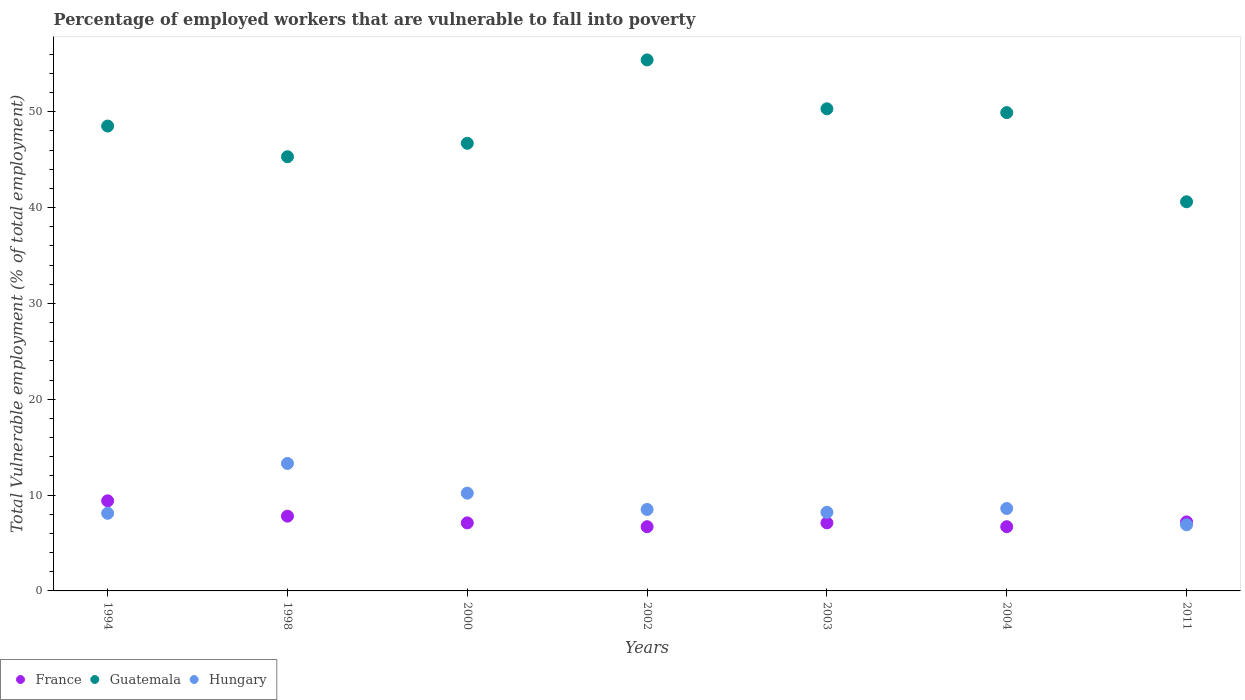How many different coloured dotlines are there?
Ensure brevity in your answer.  3. Is the number of dotlines equal to the number of legend labels?
Your answer should be very brief. Yes. What is the percentage of employed workers who are vulnerable to fall into poverty in France in 2000?
Ensure brevity in your answer.  7.1. Across all years, what is the maximum percentage of employed workers who are vulnerable to fall into poverty in Hungary?
Give a very brief answer. 13.3. Across all years, what is the minimum percentage of employed workers who are vulnerable to fall into poverty in Hungary?
Keep it short and to the point. 6.9. What is the total percentage of employed workers who are vulnerable to fall into poverty in Hungary in the graph?
Ensure brevity in your answer.  63.8. What is the difference between the percentage of employed workers who are vulnerable to fall into poverty in Guatemala in 1998 and that in 2011?
Your answer should be compact. 4.7. What is the difference between the percentage of employed workers who are vulnerable to fall into poverty in France in 2002 and the percentage of employed workers who are vulnerable to fall into poverty in Guatemala in 2003?
Your answer should be compact. -43.6. What is the average percentage of employed workers who are vulnerable to fall into poverty in Hungary per year?
Offer a very short reply. 9.11. In the year 2003, what is the difference between the percentage of employed workers who are vulnerable to fall into poverty in France and percentage of employed workers who are vulnerable to fall into poverty in Guatemala?
Offer a very short reply. -43.2. In how many years, is the percentage of employed workers who are vulnerable to fall into poverty in Guatemala greater than 4 %?
Your answer should be compact. 7. What is the ratio of the percentage of employed workers who are vulnerable to fall into poverty in France in 1998 to that in 2000?
Ensure brevity in your answer.  1.1. Is the percentage of employed workers who are vulnerable to fall into poverty in France in 1998 less than that in 2011?
Make the answer very short. No. What is the difference between the highest and the second highest percentage of employed workers who are vulnerable to fall into poverty in France?
Your answer should be very brief. 1.6. What is the difference between the highest and the lowest percentage of employed workers who are vulnerable to fall into poverty in Hungary?
Make the answer very short. 6.4. Does the percentage of employed workers who are vulnerable to fall into poverty in Guatemala monotonically increase over the years?
Offer a very short reply. No. How many dotlines are there?
Offer a terse response. 3. Are the values on the major ticks of Y-axis written in scientific E-notation?
Your answer should be very brief. No. Does the graph contain any zero values?
Make the answer very short. No. Does the graph contain grids?
Your response must be concise. No. Where does the legend appear in the graph?
Offer a terse response. Bottom left. What is the title of the graph?
Provide a short and direct response. Percentage of employed workers that are vulnerable to fall into poverty. What is the label or title of the Y-axis?
Your answer should be very brief. Total Vulnerable employment (% of total employment). What is the Total Vulnerable employment (% of total employment) of France in 1994?
Keep it short and to the point. 9.4. What is the Total Vulnerable employment (% of total employment) in Guatemala in 1994?
Keep it short and to the point. 48.5. What is the Total Vulnerable employment (% of total employment) in Hungary in 1994?
Your answer should be compact. 8.1. What is the Total Vulnerable employment (% of total employment) in France in 1998?
Your response must be concise. 7.8. What is the Total Vulnerable employment (% of total employment) in Guatemala in 1998?
Offer a terse response. 45.3. What is the Total Vulnerable employment (% of total employment) of Hungary in 1998?
Ensure brevity in your answer.  13.3. What is the Total Vulnerable employment (% of total employment) of France in 2000?
Your answer should be very brief. 7.1. What is the Total Vulnerable employment (% of total employment) in Guatemala in 2000?
Make the answer very short. 46.7. What is the Total Vulnerable employment (% of total employment) in Hungary in 2000?
Your response must be concise. 10.2. What is the Total Vulnerable employment (% of total employment) in France in 2002?
Offer a very short reply. 6.7. What is the Total Vulnerable employment (% of total employment) of Guatemala in 2002?
Keep it short and to the point. 55.4. What is the Total Vulnerable employment (% of total employment) in France in 2003?
Make the answer very short. 7.1. What is the Total Vulnerable employment (% of total employment) of Guatemala in 2003?
Offer a terse response. 50.3. What is the Total Vulnerable employment (% of total employment) of Hungary in 2003?
Your response must be concise. 8.2. What is the Total Vulnerable employment (% of total employment) in France in 2004?
Offer a very short reply. 6.7. What is the Total Vulnerable employment (% of total employment) of Guatemala in 2004?
Ensure brevity in your answer.  49.9. What is the Total Vulnerable employment (% of total employment) of Hungary in 2004?
Provide a short and direct response. 8.6. What is the Total Vulnerable employment (% of total employment) in France in 2011?
Provide a succinct answer. 7.2. What is the Total Vulnerable employment (% of total employment) in Guatemala in 2011?
Offer a very short reply. 40.6. What is the Total Vulnerable employment (% of total employment) in Hungary in 2011?
Offer a terse response. 6.9. Across all years, what is the maximum Total Vulnerable employment (% of total employment) of France?
Give a very brief answer. 9.4. Across all years, what is the maximum Total Vulnerable employment (% of total employment) in Guatemala?
Provide a succinct answer. 55.4. Across all years, what is the maximum Total Vulnerable employment (% of total employment) of Hungary?
Your response must be concise. 13.3. Across all years, what is the minimum Total Vulnerable employment (% of total employment) of France?
Your answer should be compact. 6.7. Across all years, what is the minimum Total Vulnerable employment (% of total employment) in Guatemala?
Provide a short and direct response. 40.6. Across all years, what is the minimum Total Vulnerable employment (% of total employment) of Hungary?
Your answer should be compact. 6.9. What is the total Total Vulnerable employment (% of total employment) of France in the graph?
Ensure brevity in your answer.  52. What is the total Total Vulnerable employment (% of total employment) in Guatemala in the graph?
Keep it short and to the point. 336.7. What is the total Total Vulnerable employment (% of total employment) in Hungary in the graph?
Provide a short and direct response. 63.8. What is the difference between the Total Vulnerable employment (% of total employment) in France in 1994 and that in 1998?
Your answer should be very brief. 1.6. What is the difference between the Total Vulnerable employment (% of total employment) in Guatemala in 1994 and that in 1998?
Ensure brevity in your answer.  3.2. What is the difference between the Total Vulnerable employment (% of total employment) in France in 1994 and that in 2002?
Make the answer very short. 2.7. What is the difference between the Total Vulnerable employment (% of total employment) of Hungary in 1994 and that in 2002?
Provide a succinct answer. -0.4. What is the difference between the Total Vulnerable employment (% of total employment) of France in 1994 and that in 2003?
Your response must be concise. 2.3. What is the difference between the Total Vulnerable employment (% of total employment) in Guatemala in 1994 and that in 2004?
Give a very brief answer. -1.4. What is the difference between the Total Vulnerable employment (% of total employment) of Hungary in 1994 and that in 2004?
Provide a short and direct response. -0.5. What is the difference between the Total Vulnerable employment (% of total employment) of Guatemala in 1994 and that in 2011?
Provide a short and direct response. 7.9. What is the difference between the Total Vulnerable employment (% of total employment) of France in 1998 and that in 2000?
Your response must be concise. 0.7. What is the difference between the Total Vulnerable employment (% of total employment) of Guatemala in 1998 and that in 2000?
Keep it short and to the point. -1.4. What is the difference between the Total Vulnerable employment (% of total employment) in France in 1998 and that in 2002?
Provide a short and direct response. 1.1. What is the difference between the Total Vulnerable employment (% of total employment) in Hungary in 1998 and that in 2002?
Provide a short and direct response. 4.8. What is the difference between the Total Vulnerable employment (% of total employment) of France in 1998 and that in 2003?
Make the answer very short. 0.7. What is the difference between the Total Vulnerable employment (% of total employment) in France in 1998 and that in 2011?
Your answer should be compact. 0.6. What is the difference between the Total Vulnerable employment (% of total employment) of Guatemala in 1998 and that in 2011?
Your answer should be compact. 4.7. What is the difference between the Total Vulnerable employment (% of total employment) in Guatemala in 2000 and that in 2002?
Provide a succinct answer. -8.7. What is the difference between the Total Vulnerable employment (% of total employment) of Hungary in 2000 and that in 2002?
Keep it short and to the point. 1.7. What is the difference between the Total Vulnerable employment (% of total employment) of Hungary in 2000 and that in 2003?
Make the answer very short. 2. What is the difference between the Total Vulnerable employment (% of total employment) of Hungary in 2000 and that in 2011?
Your answer should be very brief. 3.3. What is the difference between the Total Vulnerable employment (% of total employment) in France in 2002 and that in 2003?
Keep it short and to the point. -0.4. What is the difference between the Total Vulnerable employment (% of total employment) in France in 2002 and that in 2004?
Keep it short and to the point. 0. What is the difference between the Total Vulnerable employment (% of total employment) of Hungary in 2002 and that in 2004?
Provide a short and direct response. -0.1. What is the difference between the Total Vulnerable employment (% of total employment) in France in 2002 and that in 2011?
Provide a short and direct response. -0.5. What is the difference between the Total Vulnerable employment (% of total employment) of Guatemala in 2002 and that in 2011?
Keep it short and to the point. 14.8. What is the difference between the Total Vulnerable employment (% of total employment) of Hungary in 2002 and that in 2011?
Offer a very short reply. 1.6. What is the difference between the Total Vulnerable employment (% of total employment) in France in 2003 and that in 2004?
Your response must be concise. 0.4. What is the difference between the Total Vulnerable employment (% of total employment) in Guatemala in 2003 and that in 2004?
Your response must be concise. 0.4. What is the difference between the Total Vulnerable employment (% of total employment) of Hungary in 2003 and that in 2004?
Keep it short and to the point. -0.4. What is the difference between the Total Vulnerable employment (% of total employment) in Hungary in 2003 and that in 2011?
Keep it short and to the point. 1.3. What is the difference between the Total Vulnerable employment (% of total employment) of France in 1994 and the Total Vulnerable employment (% of total employment) of Guatemala in 1998?
Give a very brief answer. -35.9. What is the difference between the Total Vulnerable employment (% of total employment) of Guatemala in 1994 and the Total Vulnerable employment (% of total employment) of Hungary in 1998?
Give a very brief answer. 35.2. What is the difference between the Total Vulnerable employment (% of total employment) in France in 1994 and the Total Vulnerable employment (% of total employment) in Guatemala in 2000?
Give a very brief answer. -37.3. What is the difference between the Total Vulnerable employment (% of total employment) in Guatemala in 1994 and the Total Vulnerable employment (% of total employment) in Hungary in 2000?
Keep it short and to the point. 38.3. What is the difference between the Total Vulnerable employment (% of total employment) of France in 1994 and the Total Vulnerable employment (% of total employment) of Guatemala in 2002?
Keep it short and to the point. -46. What is the difference between the Total Vulnerable employment (% of total employment) in France in 1994 and the Total Vulnerable employment (% of total employment) in Hungary in 2002?
Offer a very short reply. 0.9. What is the difference between the Total Vulnerable employment (% of total employment) in France in 1994 and the Total Vulnerable employment (% of total employment) in Guatemala in 2003?
Keep it short and to the point. -40.9. What is the difference between the Total Vulnerable employment (% of total employment) in France in 1994 and the Total Vulnerable employment (% of total employment) in Hungary in 2003?
Your response must be concise. 1.2. What is the difference between the Total Vulnerable employment (% of total employment) of Guatemala in 1994 and the Total Vulnerable employment (% of total employment) of Hungary in 2003?
Make the answer very short. 40.3. What is the difference between the Total Vulnerable employment (% of total employment) in France in 1994 and the Total Vulnerable employment (% of total employment) in Guatemala in 2004?
Ensure brevity in your answer.  -40.5. What is the difference between the Total Vulnerable employment (% of total employment) of Guatemala in 1994 and the Total Vulnerable employment (% of total employment) of Hungary in 2004?
Offer a terse response. 39.9. What is the difference between the Total Vulnerable employment (% of total employment) of France in 1994 and the Total Vulnerable employment (% of total employment) of Guatemala in 2011?
Offer a very short reply. -31.2. What is the difference between the Total Vulnerable employment (% of total employment) in Guatemala in 1994 and the Total Vulnerable employment (% of total employment) in Hungary in 2011?
Provide a succinct answer. 41.6. What is the difference between the Total Vulnerable employment (% of total employment) in France in 1998 and the Total Vulnerable employment (% of total employment) in Guatemala in 2000?
Your response must be concise. -38.9. What is the difference between the Total Vulnerable employment (% of total employment) of France in 1998 and the Total Vulnerable employment (% of total employment) of Hungary in 2000?
Keep it short and to the point. -2.4. What is the difference between the Total Vulnerable employment (% of total employment) of Guatemala in 1998 and the Total Vulnerable employment (% of total employment) of Hungary in 2000?
Give a very brief answer. 35.1. What is the difference between the Total Vulnerable employment (% of total employment) of France in 1998 and the Total Vulnerable employment (% of total employment) of Guatemala in 2002?
Ensure brevity in your answer.  -47.6. What is the difference between the Total Vulnerable employment (% of total employment) of France in 1998 and the Total Vulnerable employment (% of total employment) of Hungary in 2002?
Offer a very short reply. -0.7. What is the difference between the Total Vulnerable employment (% of total employment) in Guatemala in 1998 and the Total Vulnerable employment (% of total employment) in Hungary in 2002?
Provide a short and direct response. 36.8. What is the difference between the Total Vulnerable employment (% of total employment) of France in 1998 and the Total Vulnerable employment (% of total employment) of Guatemala in 2003?
Make the answer very short. -42.5. What is the difference between the Total Vulnerable employment (% of total employment) in Guatemala in 1998 and the Total Vulnerable employment (% of total employment) in Hungary in 2003?
Ensure brevity in your answer.  37.1. What is the difference between the Total Vulnerable employment (% of total employment) of France in 1998 and the Total Vulnerable employment (% of total employment) of Guatemala in 2004?
Provide a short and direct response. -42.1. What is the difference between the Total Vulnerable employment (% of total employment) of France in 1998 and the Total Vulnerable employment (% of total employment) of Hungary in 2004?
Keep it short and to the point. -0.8. What is the difference between the Total Vulnerable employment (% of total employment) of Guatemala in 1998 and the Total Vulnerable employment (% of total employment) of Hungary in 2004?
Provide a succinct answer. 36.7. What is the difference between the Total Vulnerable employment (% of total employment) in France in 1998 and the Total Vulnerable employment (% of total employment) in Guatemala in 2011?
Ensure brevity in your answer.  -32.8. What is the difference between the Total Vulnerable employment (% of total employment) of Guatemala in 1998 and the Total Vulnerable employment (% of total employment) of Hungary in 2011?
Offer a very short reply. 38.4. What is the difference between the Total Vulnerable employment (% of total employment) of France in 2000 and the Total Vulnerable employment (% of total employment) of Guatemala in 2002?
Your answer should be compact. -48.3. What is the difference between the Total Vulnerable employment (% of total employment) of France in 2000 and the Total Vulnerable employment (% of total employment) of Hungary in 2002?
Give a very brief answer. -1.4. What is the difference between the Total Vulnerable employment (% of total employment) of Guatemala in 2000 and the Total Vulnerable employment (% of total employment) of Hungary in 2002?
Your answer should be very brief. 38.2. What is the difference between the Total Vulnerable employment (% of total employment) in France in 2000 and the Total Vulnerable employment (% of total employment) in Guatemala in 2003?
Make the answer very short. -43.2. What is the difference between the Total Vulnerable employment (% of total employment) of Guatemala in 2000 and the Total Vulnerable employment (% of total employment) of Hungary in 2003?
Give a very brief answer. 38.5. What is the difference between the Total Vulnerable employment (% of total employment) of France in 2000 and the Total Vulnerable employment (% of total employment) of Guatemala in 2004?
Ensure brevity in your answer.  -42.8. What is the difference between the Total Vulnerable employment (% of total employment) of France in 2000 and the Total Vulnerable employment (% of total employment) of Hungary in 2004?
Provide a succinct answer. -1.5. What is the difference between the Total Vulnerable employment (% of total employment) in Guatemala in 2000 and the Total Vulnerable employment (% of total employment) in Hungary in 2004?
Provide a succinct answer. 38.1. What is the difference between the Total Vulnerable employment (% of total employment) in France in 2000 and the Total Vulnerable employment (% of total employment) in Guatemala in 2011?
Offer a terse response. -33.5. What is the difference between the Total Vulnerable employment (% of total employment) in Guatemala in 2000 and the Total Vulnerable employment (% of total employment) in Hungary in 2011?
Provide a short and direct response. 39.8. What is the difference between the Total Vulnerable employment (% of total employment) in France in 2002 and the Total Vulnerable employment (% of total employment) in Guatemala in 2003?
Ensure brevity in your answer.  -43.6. What is the difference between the Total Vulnerable employment (% of total employment) in France in 2002 and the Total Vulnerable employment (% of total employment) in Hungary in 2003?
Provide a short and direct response. -1.5. What is the difference between the Total Vulnerable employment (% of total employment) of Guatemala in 2002 and the Total Vulnerable employment (% of total employment) of Hungary in 2003?
Offer a very short reply. 47.2. What is the difference between the Total Vulnerable employment (% of total employment) of France in 2002 and the Total Vulnerable employment (% of total employment) of Guatemala in 2004?
Keep it short and to the point. -43.2. What is the difference between the Total Vulnerable employment (% of total employment) in Guatemala in 2002 and the Total Vulnerable employment (% of total employment) in Hungary in 2004?
Provide a succinct answer. 46.8. What is the difference between the Total Vulnerable employment (% of total employment) of France in 2002 and the Total Vulnerable employment (% of total employment) of Guatemala in 2011?
Your response must be concise. -33.9. What is the difference between the Total Vulnerable employment (% of total employment) of Guatemala in 2002 and the Total Vulnerable employment (% of total employment) of Hungary in 2011?
Your answer should be compact. 48.5. What is the difference between the Total Vulnerable employment (% of total employment) of France in 2003 and the Total Vulnerable employment (% of total employment) of Guatemala in 2004?
Your answer should be compact. -42.8. What is the difference between the Total Vulnerable employment (% of total employment) in France in 2003 and the Total Vulnerable employment (% of total employment) in Hungary in 2004?
Give a very brief answer. -1.5. What is the difference between the Total Vulnerable employment (% of total employment) of Guatemala in 2003 and the Total Vulnerable employment (% of total employment) of Hungary in 2004?
Offer a very short reply. 41.7. What is the difference between the Total Vulnerable employment (% of total employment) in France in 2003 and the Total Vulnerable employment (% of total employment) in Guatemala in 2011?
Give a very brief answer. -33.5. What is the difference between the Total Vulnerable employment (% of total employment) in Guatemala in 2003 and the Total Vulnerable employment (% of total employment) in Hungary in 2011?
Offer a very short reply. 43.4. What is the difference between the Total Vulnerable employment (% of total employment) of France in 2004 and the Total Vulnerable employment (% of total employment) of Guatemala in 2011?
Your answer should be very brief. -33.9. What is the average Total Vulnerable employment (% of total employment) in France per year?
Offer a terse response. 7.43. What is the average Total Vulnerable employment (% of total employment) of Guatemala per year?
Ensure brevity in your answer.  48.1. What is the average Total Vulnerable employment (% of total employment) of Hungary per year?
Your response must be concise. 9.11. In the year 1994, what is the difference between the Total Vulnerable employment (% of total employment) in France and Total Vulnerable employment (% of total employment) in Guatemala?
Offer a very short reply. -39.1. In the year 1994, what is the difference between the Total Vulnerable employment (% of total employment) of France and Total Vulnerable employment (% of total employment) of Hungary?
Offer a terse response. 1.3. In the year 1994, what is the difference between the Total Vulnerable employment (% of total employment) in Guatemala and Total Vulnerable employment (% of total employment) in Hungary?
Your response must be concise. 40.4. In the year 1998, what is the difference between the Total Vulnerable employment (% of total employment) in France and Total Vulnerable employment (% of total employment) in Guatemala?
Provide a succinct answer. -37.5. In the year 1998, what is the difference between the Total Vulnerable employment (% of total employment) in France and Total Vulnerable employment (% of total employment) in Hungary?
Make the answer very short. -5.5. In the year 2000, what is the difference between the Total Vulnerable employment (% of total employment) of France and Total Vulnerable employment (% of total employment) of Guatemala?
Keep it short and to the point. -39.6. In the year 2000, what is the difference between the Total Vulnerable employment (% of total employment) in France and Total Vulnerable employment (% of total employment) in Hungary?
Keep it short and to the point. -3.1. In the year 2000, what is the difference between the Total Vulnerable employment (% of total employment) of Guatemala and Total Vulnerable employment (% of total employment) of Hungary?
Provide a short and direct response. 36.5. In the year 2002, what is the difference between the Total Vulnerable employment (% of total employment) of France and Total Vulnerable employment (% of total employment) of Guatemala?
Provide a short and direct response. -48.7. In the year 2002, what is the difference between the Total Vulnerable employment (% of total employment) in Guatemala and Total Vulnerable employment (% of total employment) in Hungary?
Give a very brief answer. 46.9. In the year 2003, what is the difference between the Total Vulnerable employment (% of total employment) of France and Total Vulnerable employment (% of total employment) of Guatemala?
Make the answer very short. -43.2. In the year 2003, what is the difference between the Total Vulnerable employment (% of total employment) of Guatemala and Total Vulnerable employment (% of total employment) of Hungary?
Provide a short and direct response. 42.1. In the year 2004, what is the difference between the Total Vulnerable employment (% of total employment) of France and Total Vulnerable employment (% of total employment) of Guatemala?
Provide a succinct answer. -43.2. In the year 2004, what is the difference between the Total Vulnerable employment (% of total employment) in Guatemala and Total Vulnerable employment (% of total employment) in Hungary?
Your answer should be very brief. 41.3. In the year 2011, what is the difference between the Total Vulnerable employment (% of total employment) in France and Total Vulnerable employment (% of total employment) in Guatemala?
Make the answer very short. -33.4. In the year 2011, what is the difference between the Total Vulnerable employment (% of total employment) in France and Total Vulnerable employment (% of total employment) in Hungary?
Provide a short and direct response. 0.3. In the year 2011, what is the difference between the Total Vulnerable employment (% of total employment) in Guatemala and Total Vulnerable employment (% of total employment) in Hungary?
Give a very brief answer. 33.7. What is the ratio of the Total Vulnerable employment (% of total employment) of France in 1994 to that in 1998?
Your answer should be compact. 1.21. What is the ratio of the Total Vulnerable employment (% of total employment) of Guatemala in 1994 to that in 1998?
Your response must be concise. 1.07. What is the ratio of the Total Vulnerable employment (% of total employment) in Hungary in 1994 to that in 1998?
Offer a very short reply. 0.61. What is the ratio of the Total Vulnerable employment (% of total employment) in France in 1994 to that in 2000?
Your answer should be compact. 1.32. What is the ratio of the Total Vulnerable employment (% of total employment) of Guatemala in 1994 to that in 2000?
Make the answer very short. 1.04. What is the ratio of the Total Vulnerable employment (% of total employment) of Hungary in 1994 to that in 2000?
Offer a very short reply. 0.79. What is the ratio of the Total Vulnerable employment (% of total employment) in France in 1994 to that in 2002?
Make the answer very short. 1.4. What is the ratio of the Total Vulnerable employment (% of total employment) in Guatemala in 1994 to that in 2002?
Provide a succinct answer. 0.88. What is the ratio of the Total Vulnerable employment (% of total employment) in Hungary in 1994 to that in 2002?
Your answer should be very brief. 0.95. What is the ratio of the Total Vulnerable employment (% of total employment) of France in 1994 to that in 2003?
Provide a short and direct response. 1.32. What is the ratio of the Total Vulnerable employment (% of total employment) of Guatemala in 1994 to that in 2003?
Provide a short and direct response. 0.96. What is the ratio of the Total Vulnerable employment (% of total employment) of France in 1994 to that in 2004?
Offer a very short reply. 1.4. What is the ratio of the Total Vulnerable employment (% of total employment) in Guatemala in 1994 to that in 2004?
Ensure brevity in your answer.  0.97. What is the ratio of the Total Vulnerable employment (% of total employment) in Hungary in 1994 to that in 2004?
Your response must be concise. 0.94. What is the ratio of the Total Vulnerable employment (% of total employment) in France in 1994 to that in 2011?
Keep it short and to the point. 1.31. What is the ratio of the Total Vulnerable employment (% of total employment) in Guatemala in 1994 to that in 2011?
Your answer should be very brief. 1.19. What is the ratio of the Total Vulnerable employment (% of total employment) of Hungary in 1994 to that in 2011?
Ensure brevity in your answer.  1.17. What is the ratio of the Total Vulnerable employment (% of total employment) in France in 1998 to that in 2000?
Your answer should be compact. 1.1. What is the ratio of the Total Vulnerable employment (% of total employment) in Guatemala in 1998 to that in 2000?
Offer a terse response. 0.97. What is the ratio of the Total Vulnerable employment (% of total employment) in Hungary in 1998 to that in 2000?
Ensure brevity in your answer.  1.3. What is the ratio of the Total Vulnerable employment (% of total employment) in France in 1998 to that in 2002?
Your answer should be compact. 1.16. What is the ratio of the Total Vulnerable employment (% of total employment) of Guatemala in 1998 to that in 2002?
Your response must be concise. 0.82. What is the ratio of the Total Vulnerable employment (% of total employment) of Hungary in 1998 to that in 2002?
Give a very brief answer. 1.56. What is the ratio of the Total Vulnerable employment (% of total employment) of France in 1998 to that in 2003?
Your answer should be very brief. 1.1. What is the ratio of the Total Vulnerable employment (% of total employment) in Guatemala in 1998 to that in 2003?
Offer a terse response. 0.9. What is the ratio of the Total Vulnerable employment (% of total employment) of Hungary in 1998 to that in 2003?
Provide a short and direct response. 1.62. What is the ratio of the Total Vulnerable employment (% of total employment) in France in 1998 to that in 2004?
Keep it short and to the point. 1.16. What is the ratio of the Total Vulnerable employment (% of total employment) in Guatemala in 1998 to that in 2004?
Provide a succinct answer. 0.91. What is the ratio of the Total Vulnerable employment (% of total employment) of Hungary in 1998 to that in 2004?
Offer a terse response. 1.55. What is the ratio of the Total Vulnerable employment (% of total employment) of France in 1998 to that in 2011?
Provide a succinct answer. 1.08. What is the ratio of the Total Vulnerable employment (% of total employment) of Guatemala in 1998 to that in 2011?
Make the answer very short. 1.12. What is the ratio of the Total Vulnerable employment (% of total employment) in Hungary in 1998 to that in 2011?
Make the answer very short. 1.93. What is the ratio of the Total Vulnerable employment (% of total employment) in France in 2000 to that in 2002?
Ensure brevity in your answer.  1.06. What is the ratio of the Total Vulnerable employment (% of total employment) of Guatemala in 2000 to that in 2002?
Give a very brief answer. 0.84. What is the ratio of the Total Vulnerable employment (% of total employment) of Guatemala in 2000 to that in 2003?
Offer a terse response. 0.93. What is the ratio of the Total Vulnerable employment (% of total employment) in Hungary in 2000 to that in 2003?
Offer a terse response. 1.24. What is the ratio of the Total Vulnerable employment (% of total employment) of France in 2000 to that in 2004?
Provide a succinct answer. 1.06. What is the ratio of the Total Vulnerable employment (% of total employment) of Guatemala in 2000 to that in 2004?
Make the answer very short. 0.94. What is the ratio of the Total Vulnerable employment (% of total employment) of Hungary in 2000 to that in 2004?
Provide a succinct answer. 1.19. What is the ratio of the Total Vulnerable employment (% of total employment) of France in 2000 to that in 2011?
Offer a terse response. 0.99. What is the ratio of the Total Vulnerable employment (% of total employment) in Guatemala in 2000 to that in 2011?
Offer a very short reply. 1.15. What is the ratio of the Total Vulnerable employment (% of total employment) in Hungary in 2000 to that in 2011?
Give a very brief answer. 1.48. What is the ratio of the Total Vulnerable employment (% of total employment) in France in 2002 to that in 2003?
Ensure brevity in your answer.  0.94. What is the ratio of the Total Vulnerable employment (% of total employment) of Guatemala in 2002 to that in 2003?
Keep it short and to the point. 1.1. What is the ratio of the Total Vulnerable employment (% of total employment) in Hungary in 2002 to that in 2003?
Your answer should be compact. 1.04. What is the ratio of the Total Vulnerable employment (% of total employment) in Guatemala in 2002 to that in 2004?
Give a very brief answer. 1.11. What is the ratio of the Total Vulnerable employment (% of total employment) in Hungary in 2002 to that in 2004?
Give a very brief answer. 0.99. What is the ratio of the Total Vulnerable employment (% of total employment) in France in 2002 to that in 2011?
Ensure brevity in your answer.  0.93. What is the ratio of the Total Vulnerable employment (% of total employment) of Guatemala in 2002 to that in 2011?
Ensure brevity in your answer.  1.36. What is the ratio of the Total Vulnerable employment (% of total employment) of Hungary in 2002 to that in 2011?
Offer a terse response. 1.23. What is the ratio of the Total Vulnerable employment (% of total employment) of France in 2003 to that in 2004?
Provide a short and direct response. 1.06. What is the ratio of the Total Vulnerable employment (% of total employment) of Hungary in 2003 to that in 2004?
Provide a succinct answer. 0.95. What is the ratio of the Total Vulnerable employment (% of total employment) of France in 2003 to that in 2011?
Provide a short and direct response. 0.99. What is the ratio of the Total Vulnerable employment (% of total employment) of Guatemala in 2003 to that in 2011?
Keep it short and to the point. 1.24. What is the ratio of the Total Vulnerable employment (% of total employment) of Hungary in 2003 to that in 2011?
Your answer should be compact. 1.19. What is the ratio of the Total Vulnerable employment (% of total employment) in France in 2004 to that in 2011?
Offer a terse response. 0.93. What is the ratio of the Total Vulnerable employment (% of total employment) of Guatemala in 2004 to that in 2011?
Offer a very short reply. 1.23. What is the ratio of the Total Vulnerable employment (% of total employment) of Hungary in 2004 to that in 2011?
Ensure brevity in your answer.  1.25. What is the difference between the highest and the second highest Total Vulnerable employment (% of total employment) in France?
Offer a very short reply. 1.6. What is the difference between the highest and the second highest Total Vulnerable employment (% of total employment) of Guatemala?
Ensure brevity in your answer.  5.1. What is the difference between the highest and the second highest Total Vulnerable employment (% of total employment) in Hungary?
Ensure brevity in your answer.  3.1. What is the difference between the highest and the lowest Total Vulnerable employment (% of total employment) of France?
Offer a terse response. 2.7. 